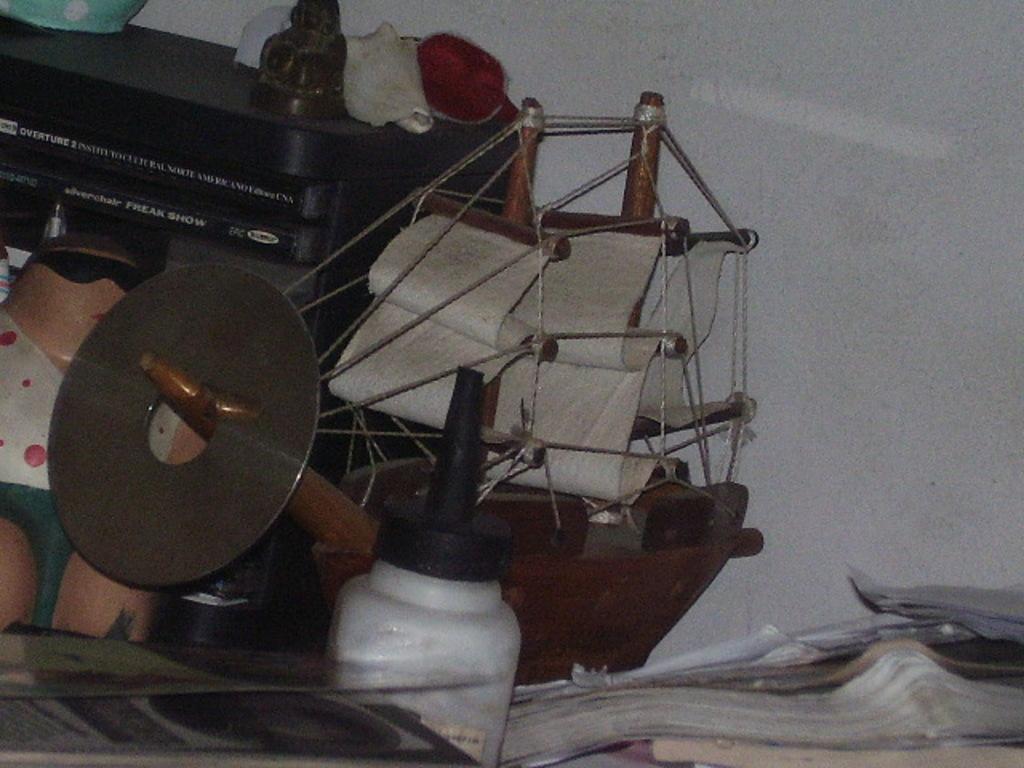How would you summarize this image in a sentence or two? In this image we can see a bottle, books, toy boat, another toy and some other items. In the back there is a wall. 